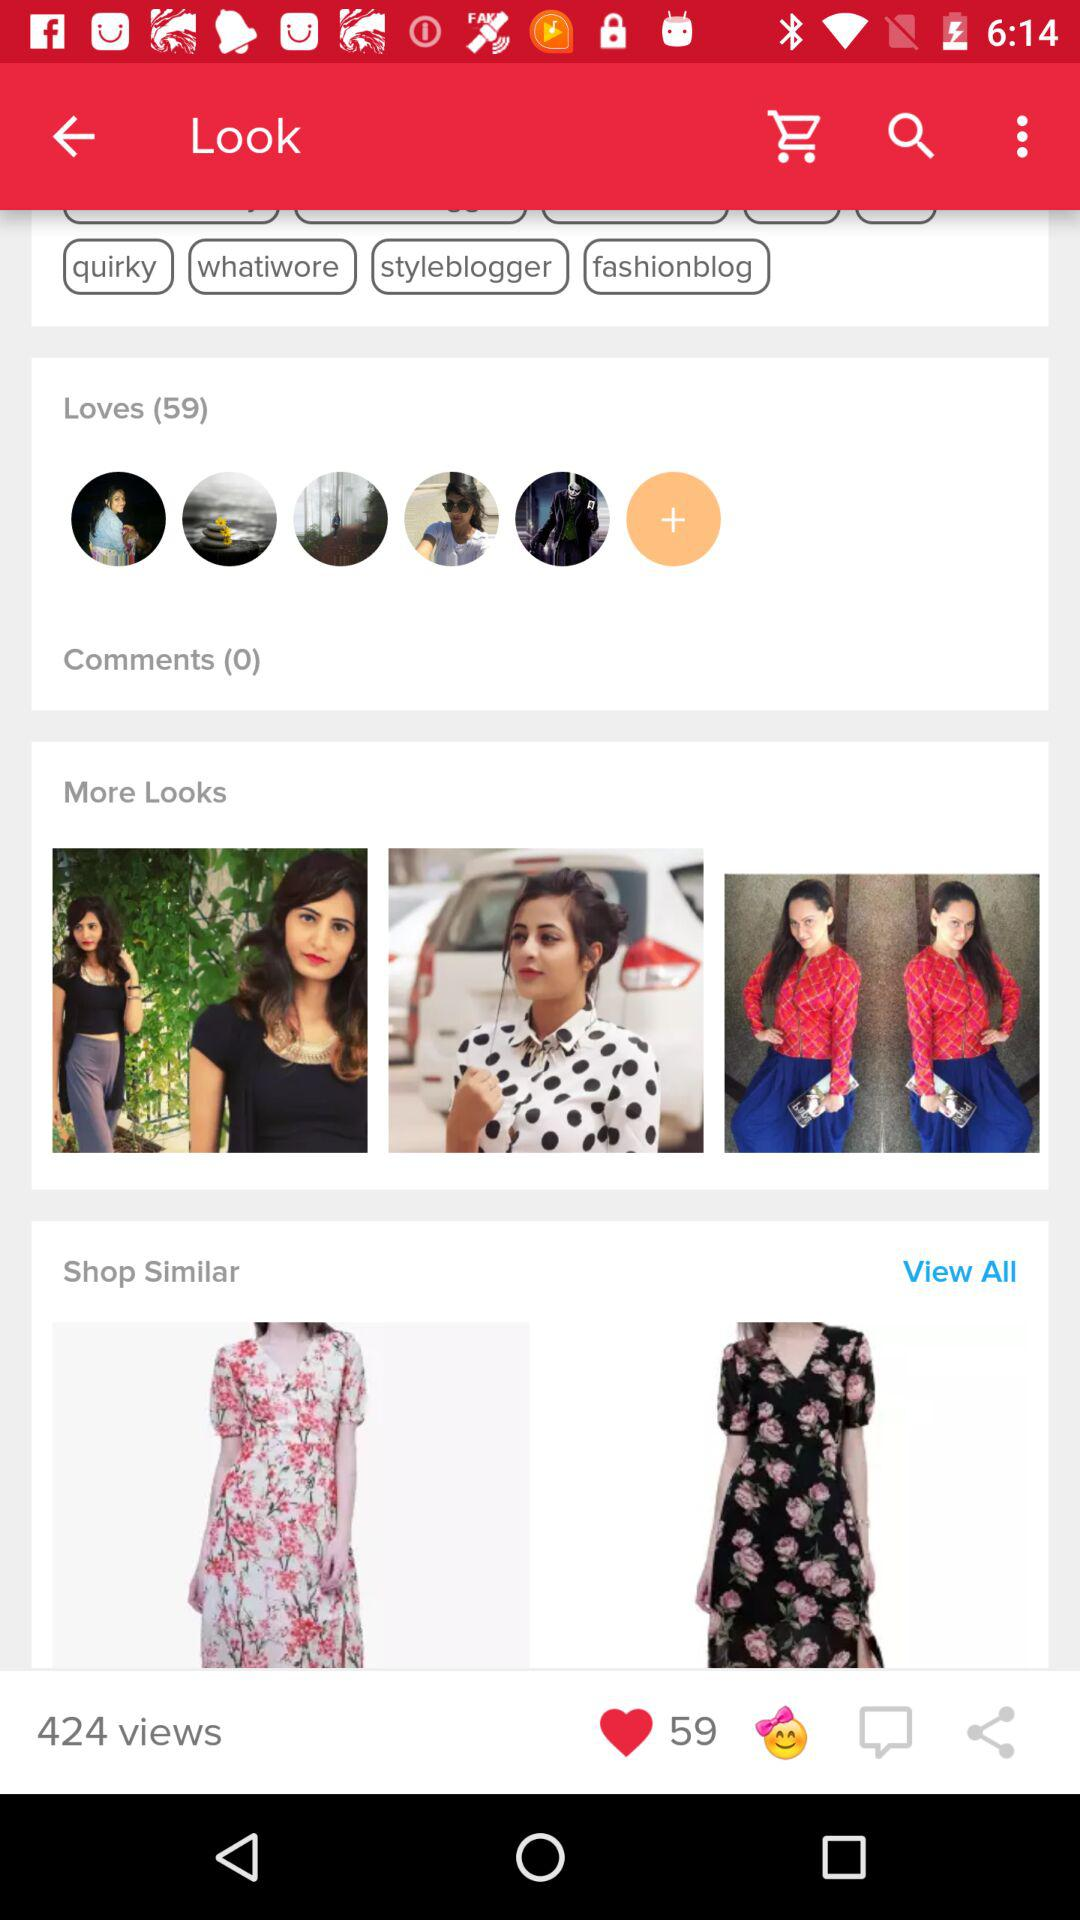How many "Loves" were there? The number of "Loves" is 59. 